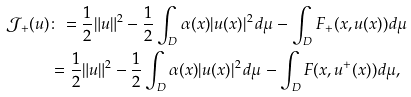<formula> <loc_0><loc_0><loc_500><loc_500>\mathcal { J } _ { + } ( u ) & \colon = \frac { 1 } { 2 } \| u \| ^ { 2 } - \frac { 1 } { 2 } \int _ { D } { \alpha ( x ) } | u ( x ) | ^ { 2 } \, d \mu - \int _ { D } F _ { + } ( x , u ( x ) ) d \mu \\ & = \frac { 1 } { 2 } \| u \| ^ { 2 } - \frac { 1 } { 2 } \int _ { D } { \alpha ( x ) } | u ( x ) | ^ { 2 } \, d \mu - \int _ { D } F ( x , u ^ { + } ( x ) ) d \mu ,</formula> 